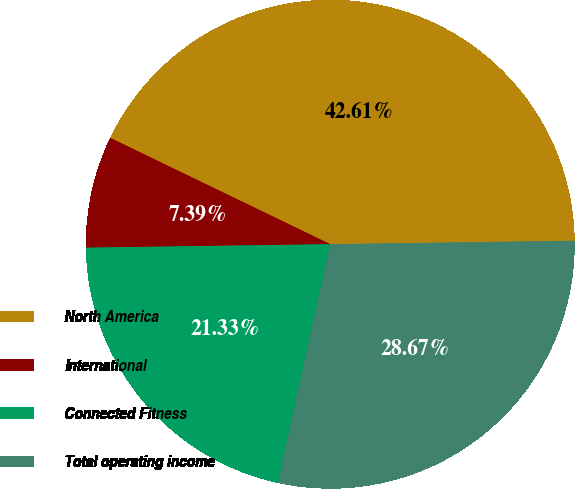Convert chart. <chart><loc_0><loc_0><loc_500><loc_500><pie_chart><fcel>North America<fcel>International<fcel>Connected Fitness<fcel>Total operating income<nl><fcel>42.61%<fcel>7.39%<fcel>21.33%<fcel>28.67%<nl></chart> 